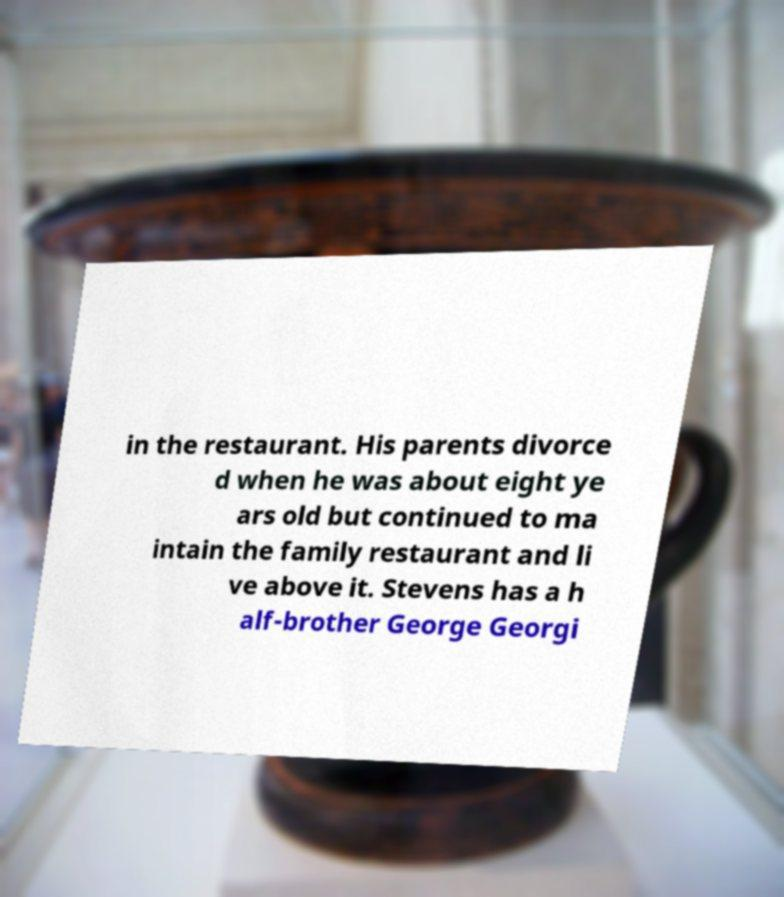I need the written content from this picture converted into text. Can you do that? in the restaurant. His parents divorce d when he was about eight ye ars old but continued to ma intain the family restaurant and li ve above it. Stevens has a h alf-brother George Georgi 